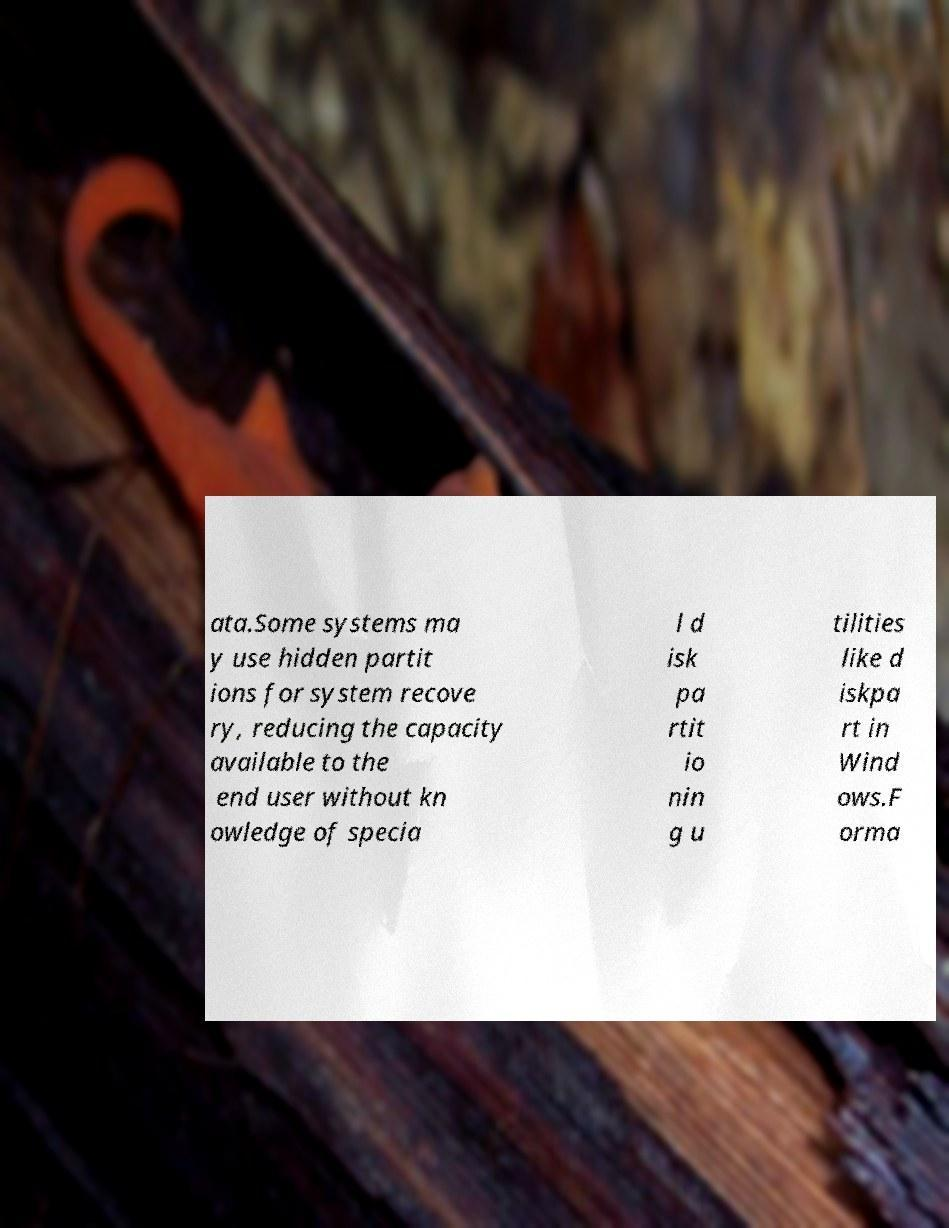Please identify and transcribe the text found in this image. ata.Some systems ma y use hidden partit ions for system recove ry, reducing the capacity available to the end user without kn owledge of specia l d isk pa rtit io nin g u tilities like d iskpa rt in Wind ows.F orma 